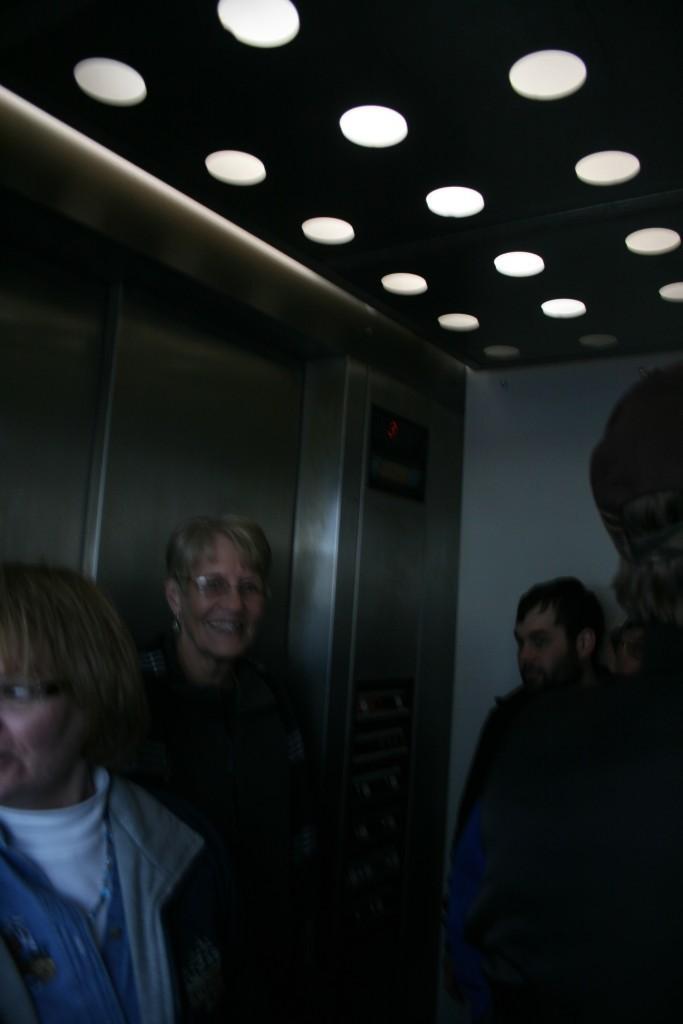Describe this image in one or two sentences. In this picture I can see a lift, in which there are few people and I see number of lights on top of this image. In the background I can see a woman who is smiling. 